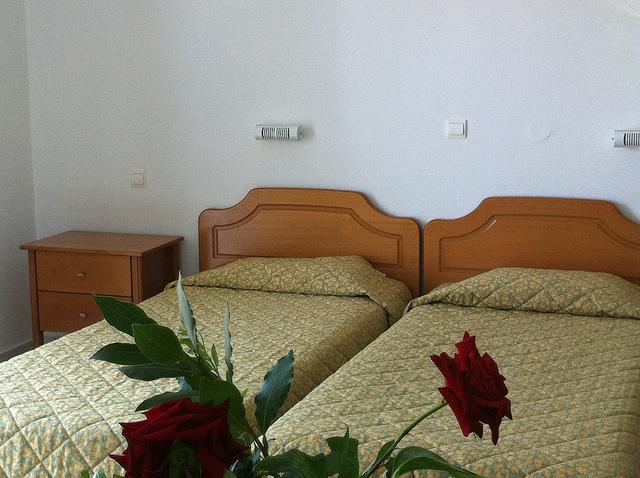Does each bed have a pillow?
Concise answer only. Yes. What size beds are these?
Short answer required. Twin. Do the quilts match?
Write a very short answer. Yes. 